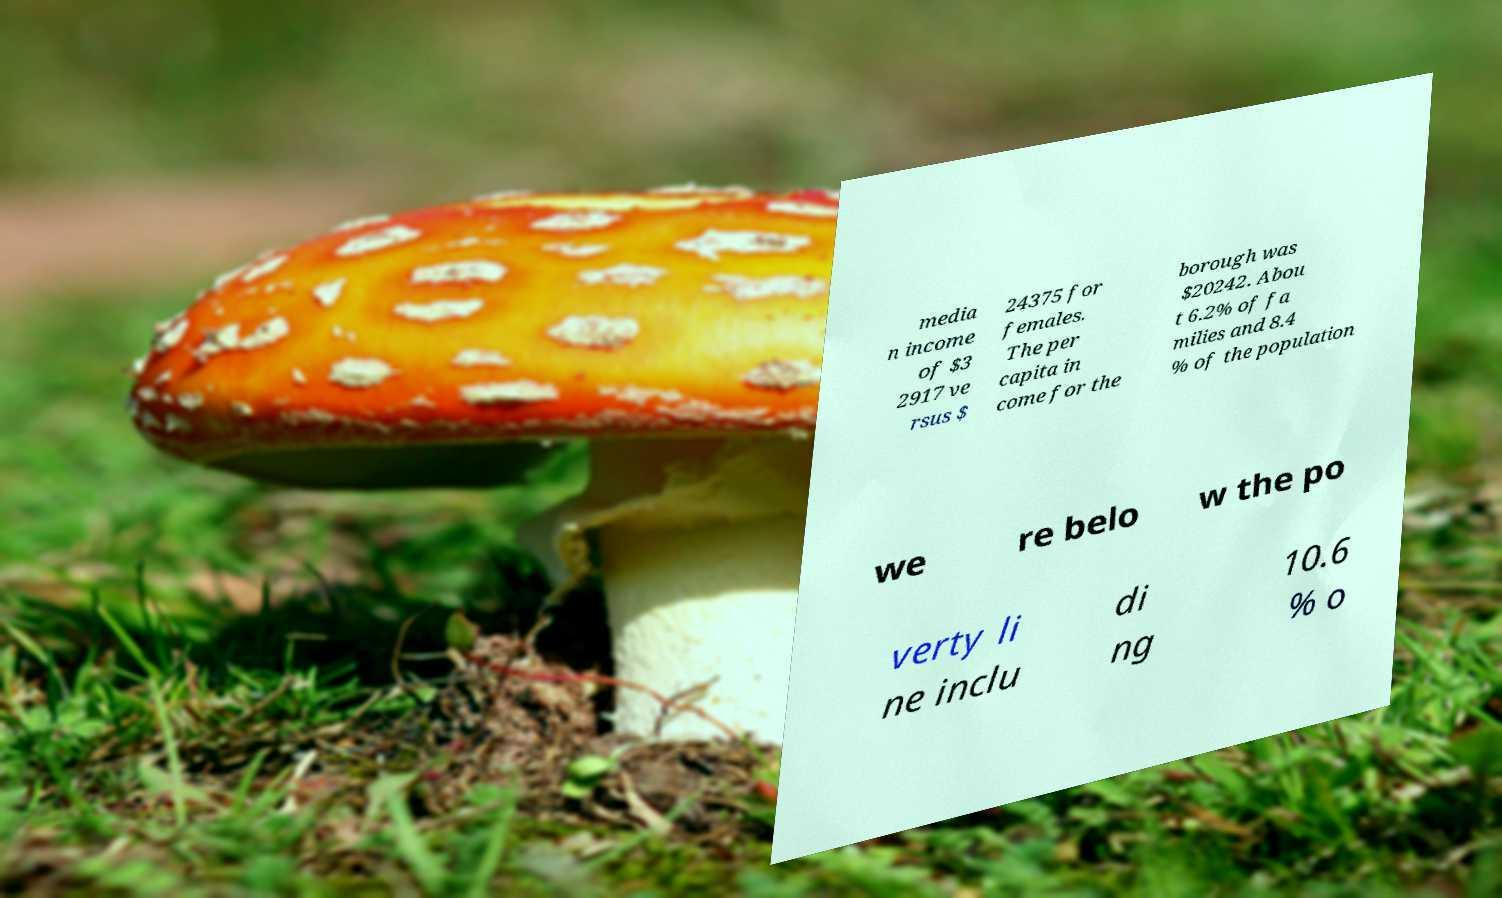I need the written content from this picture converted into text. Can you do that? media n income of $3 2917 ve rsus $ 24375 for females. The per capita in come for the borough was $20242. Abou t 6.2% of fa milies and 8.4 % of the population we re belo w the po verty li ne inclu di ng 10.6 % o 